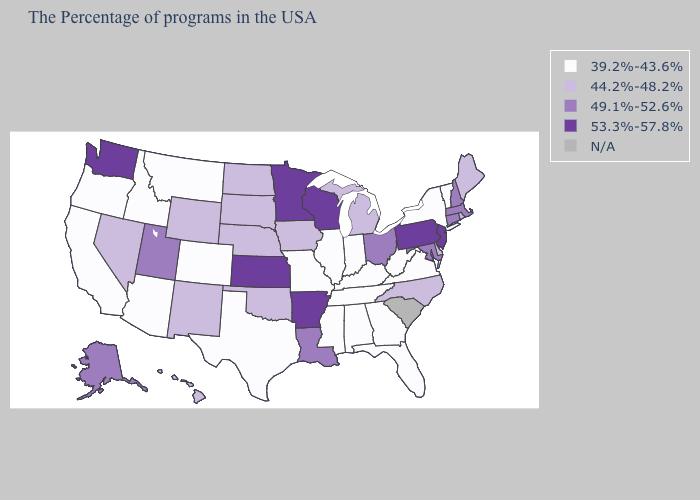What is the value of Wyoming?
Quick response, please. 44.2%-48.2%. Name the states that have a value in the range 53.3%-57.8%?
Concise answer only. New Jersey, Pennsylvania, Wisconsin, Arkansas, Minnesota, Kansas, Washington. Among the states that border North Carolina , which have the highest value?
Give a very brief answer. Virginia, Georgia, Tennessee. Name the states that have a value in the range 44.2%-48.2%?
Write a very short answer. Maine, Rhode Island, Delaware, North Carolina, Michigan, Iowa, Nebraska, Oklahoma, South Dakota, North Dakota, Wyoming, New Mexico, Nevada, Hawaii. Name the states that have a value in the range 44.2%-48.2%?
Answer briefly. Maine, Rhode Island, Delaware, North Carolina, Michigan, Iowa, Nebraska, Oklahoma, South Dakota, North Dakota, Wyoming, New Mexico, Nevada, Hawaii. Among the states that border Oklahoma , which have the lowest value?
Write a very short answer. Missouri, Texas, Colorado. Among the states that border South Carolina , which have the lowest value?
Give a very brief answer. Georgia. Name the states that have a value in the range 49.1%-52.6%?
Give a very brief answer. Massachusetts, New Hampshire, Connecticut, Maryland, Ohio, Louisiana, Utah, Alaska. Among the states that border Colorado , does Kansas have the highest value?
Give a very brief answer. Yes. Name the states that have a value in the range 39.2%-43.6%?
Quick response, please. Vermont, New York, Virginia, West Virginia, Florida, Georgia, Kentucky, Indiana, Alabama, Tennessee, Illinois, Mississippi, Missouri, Texas, Colorado, Montana, Arizona, Idaho, California, Oregon. Which states have the lowest value in the USA?
Quick response, please. Vermont, New York, Virginia, West Virginia, Florida, Georgia, Kentucky, Indiana, Alabama, Tennessee, Illinois, Mississippi, Missouri, Texas, Colorado, Montana, Arizona, Idaho, California, Oregon. Name the states that have a value in the range 49.1%-52.6%?
Keep it brief. Massachusetts, New Hampshire, Connecticut, Maryland, Ohio, Louisiana, Utah, Alaska. What is the value of Nebraska?
Short answer required. 44.2%-48.2%. What is the value of Maine?
Keep it brief. 44.2%-48.2%. What is the value of Florida?
Be succinct. 39.2%-43.6%. 